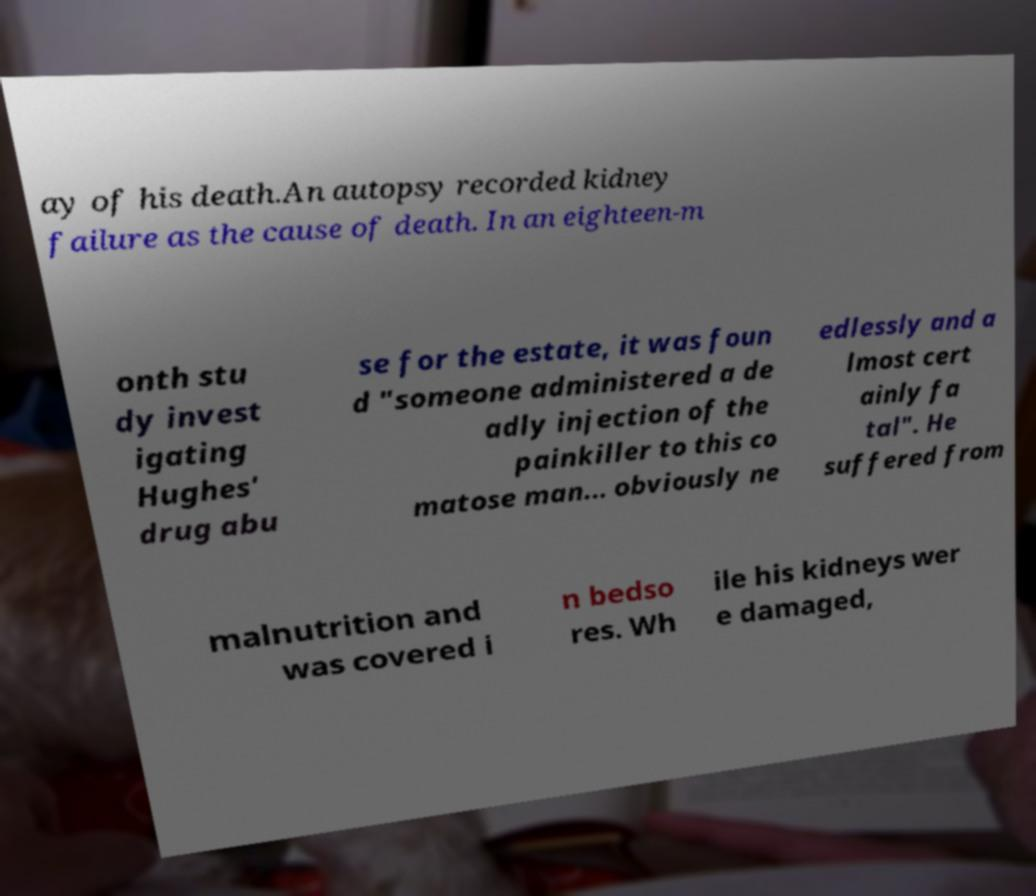Can you accurately transcribe the text from the provided image for me? ay of his death.An autopsy recorded kidney failure as the cause of death. In an eighteen-m onth stu dy invest igating Hughes' drug abu se for the estate, it was foun d "someone administered a de adly injection of the painkiller to this co matose man... obviously ne edlessly and a lmost cert ainly fa tal". He suffered from malnutrition and was covered i n bedso res. Wh ile his kidneys wer e damaged, 